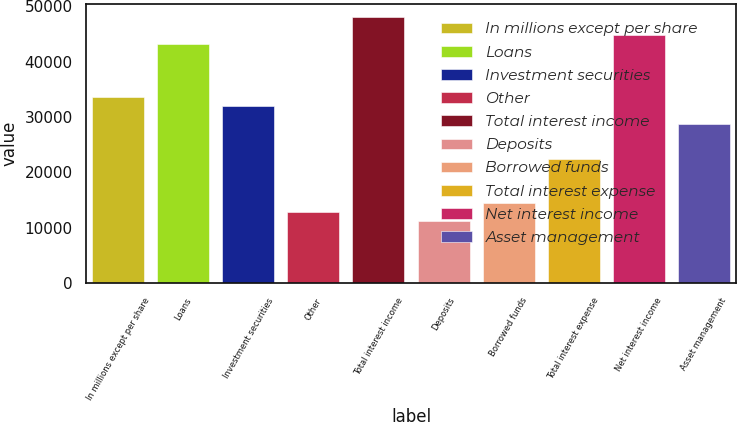Convert chart. <chart><loc_0><loc_0><loc_500><loc_500><bar_chart><fcel>In millions except per share<fcel>Loans<fcel>Investment securities<fcel>Other<fcel>Total interest income<fcel>Deposits<fcel>Borrowed funds<fcel>Total interest expense<fcel>Net interest income<fcel>Asset management<nl><fcel>33617<fcel>43219.8<fcel>32016.6<fcel>12811<fcel>48021.2<fcel>11210.6<fcel>14411.5<fcel>22413.8<fcel>44820.2<fcel>28815.6<nl></chart> 